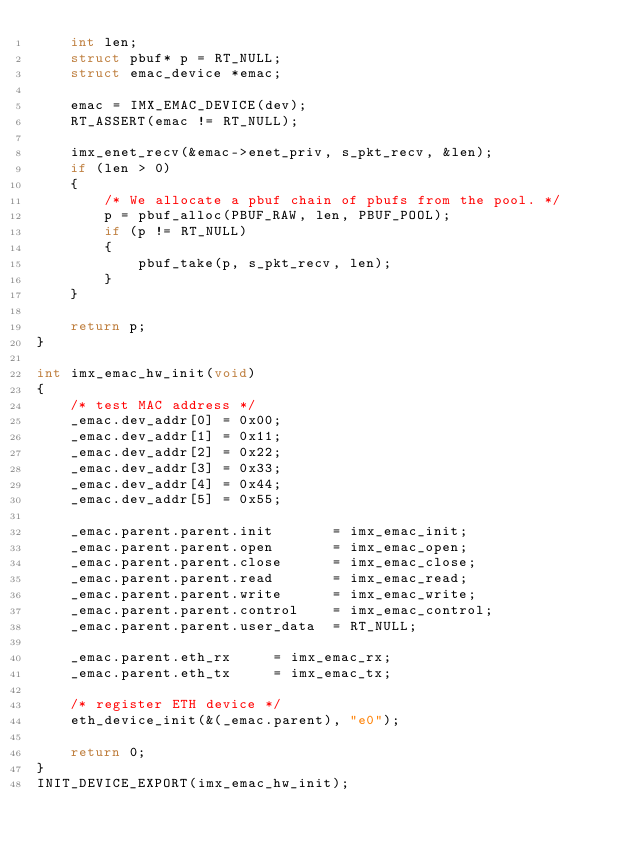<code> <loc_0><loc_0><loc_500><loc_500><_C_>    int len;
    struct pbuf* p = RT_NULL;
    struct emac_device *emac;

    emac = IMX_EMAC_DEVICE(dev);
    RT_ASSERT(emac != RT_NULL);

    imx_enet_recv(&emac->enet_priv, s_pkt_recv, &len);
    if (len > 0)
    {
        /* We allocate a pbuf chain of pbufs from the pool. */
        p = pbuf_alloc(PBUF_RAW, len, PBUF_POOL);
        if (p != RT_NULL)
        {
            pbuf_take(p, s_pkt_recv, len);
        }
    }

    return p;
}

int imx_emac_hw_init(void)
{
    /* test MAC address */
    _emac.dev_addr[0] = 0x00;
    _emac.dev_addr[1] = 0x11;
    _emac.dev_addr[2] = 0x22;
    _emac.dev_addr[3] = 0x33;
    _emac.dev_addr[4] = 0x44;
    _emac.dev_addr[5] = 0x55;

    _emac.parent.parent.init       = imx_emac_init;
    _emac.parent.parent.open       = imx_emac_open;
    _emac.parent.parent.close      = imx_emac_close;
    _emac.parent.parent.read       = imx_emac_read;
    _emac.parent.parent.write      = imx_emac_write;
    _emac.parent.parent.control    = imx_emac_control;
    _emac.parent.parent.user_data  = RT_NULL;

    _emac.parent.eth_rx     = imx_emac_rx;
    _emac.parent.eth_tx     = imx_emac_tx;

    /* register ETH device */
    eth_device_init(&(_emac.parent), "e0");

    return 0;
}
INIT_DEVICE_EXPORT(imx_emac_hw_init);
</code> 